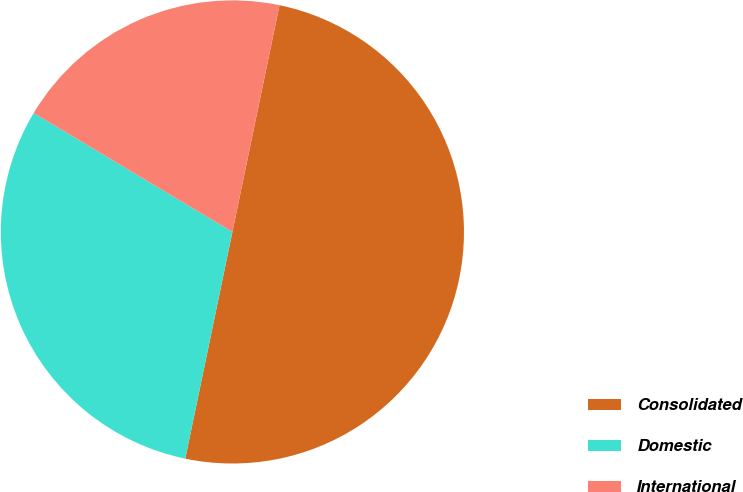Convert chart to OTSL. <chart><loc_0><loc_0><loc_500><loc_500><pie_chart><fcel>Consolidated<fcel>Domestic<fcel>International<nl><fcel>50.0%<fcel>30.32%<fcel>19.68%<nl></chart> 